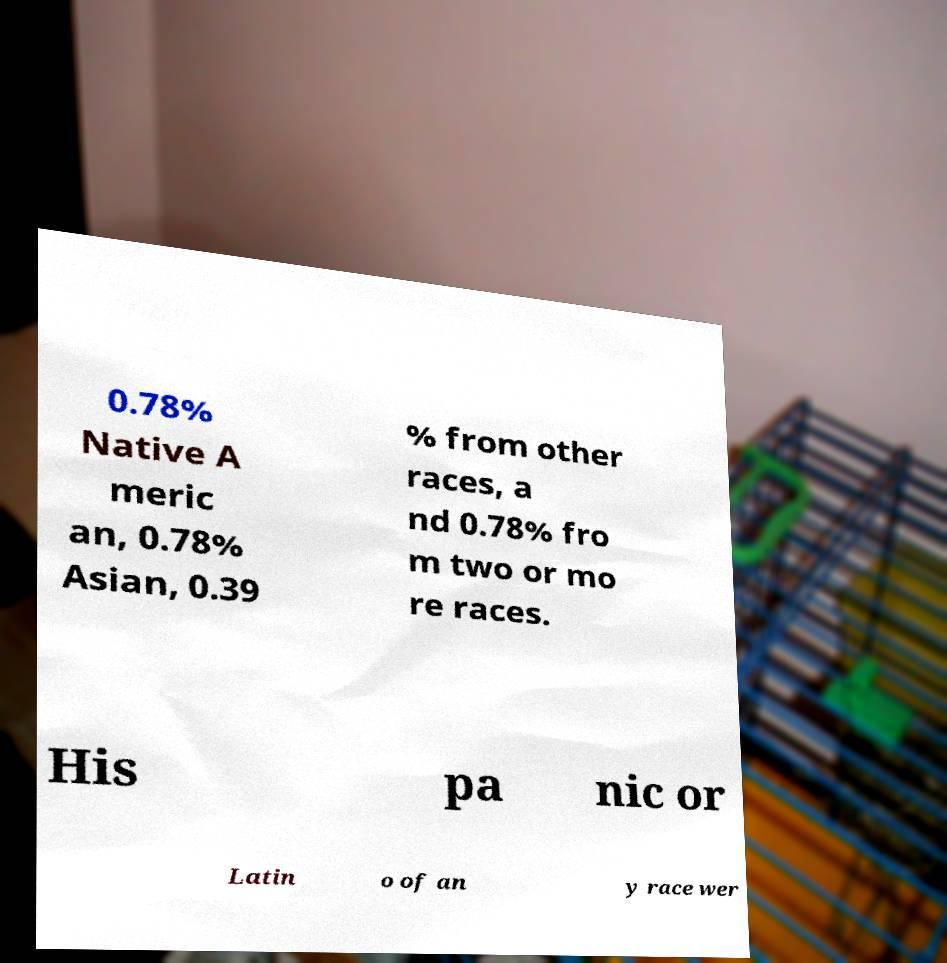For documentation purposes, I need the text within this image transcribed. Could you provide that? 0.78% Native A meric an, 0.78% Asian, 0.39 % from other races, a nd 0.78% fro m two or mo re races. His pa nic or Latin o of an y race wer 